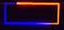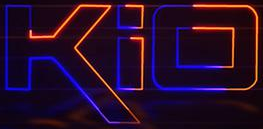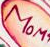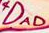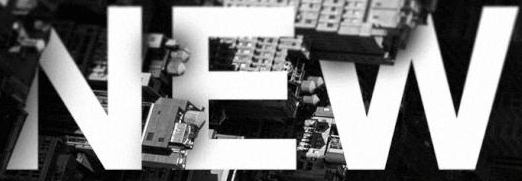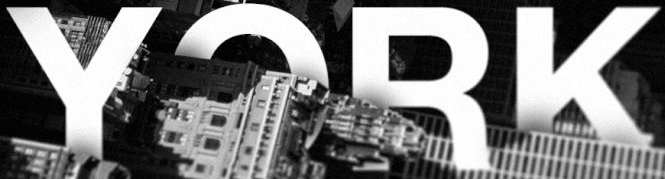Identify the words shown in these images in order, separated by a semicolon. -; kio; MOM; DAD; NEW; YORK 